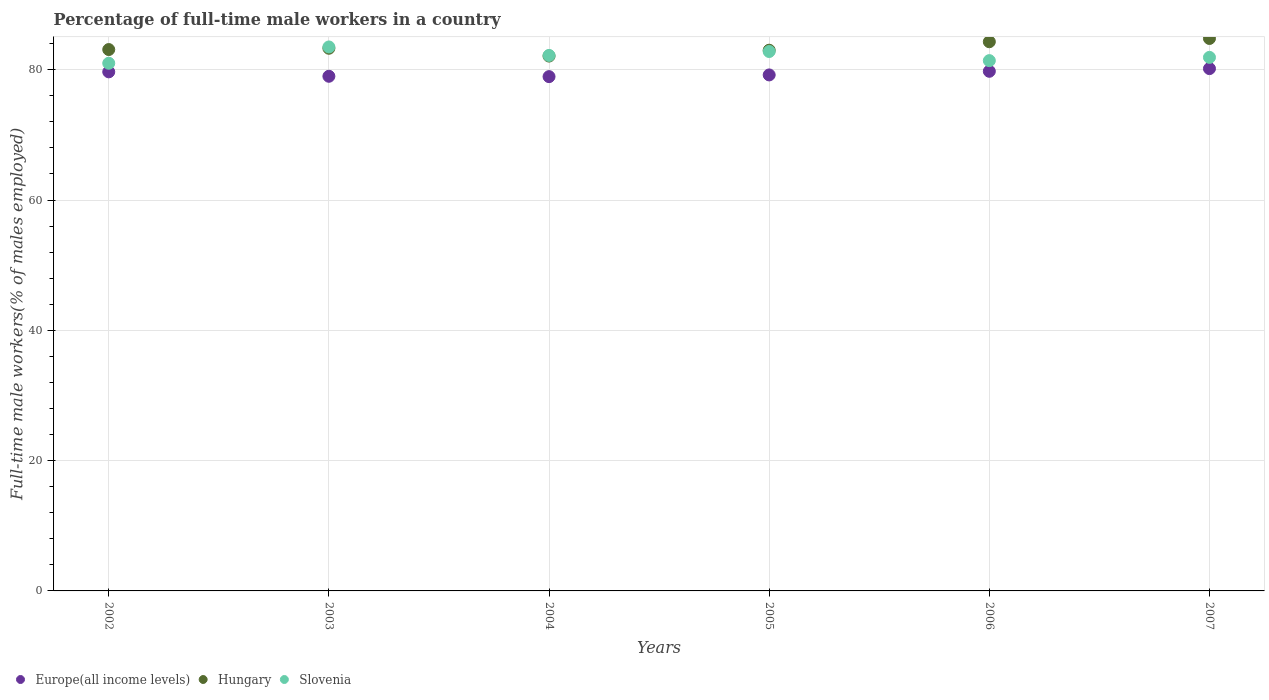Is the number of dotlines equal to the number of legend labels?
Offer a very short reply. Yes. What is the percentage of full-time male workers in Slovenia in 2006?
Offer a terse response. 81.4. Across all years, what is the maximum percentage of full-time male workers in Hungary?
Your answer should be very brief. 84.8. Across all years, what is the minimum percentage of full-time male workers in Europe(all income levels)?
Provide a short and direct response. 78.94. What is the total percentage of full-time male workers in Slovenia in the graph?
Provide a succinct answer. 492.8. What is the difference between the percentage of full-time male workers in Hungary in 2004 and that in 2005?
Ensure brevity in your answer.  -0.9. What is the difference between the percentage of full-time male workers in Europe(all income levels) in 2006 and the percentage of full-time male workers in Slovenia in 2004?
Provide a short and direct response. -2.44. What is the average percentage of full-time male workers in Europe(all income levels) per year?
Keep it short and to the point. 79.46. In the year 2007, what is the difference between the percentage of full-time male workers in Hungary and percentage of full-time male workers in Europe(all income levels)?
Provide a short and direct response. 4.63. What is the ratio of the percentage of full-time male workers in Slovenia in 2002 to that in 2006?
Your response must be concise. 1. Is the percentage of full-time male workers in Slovenia in 2004 less than that in 2007?
Ensure brevity in your answer.  No. Is the difference between the percentage of full-time male workers in Hungary in 2003 and 2006 greater than the difference between the percentage of full-time male workers in Europe(all income levels) in 2003 and 2006?
Provide a short and direct response. No. What is the difference between the highest and the second highest percentage of full-time male workers in Slovenia?
Ensure brevity in your answer.  0.7. What is the difference between the highest and the lowest percentage of full-time male workers in Europe(all income levels)?
Give a very brief answer. 1.23. Does the percentage of full-time male workers in Europe(all income levels) monotonically increase over the years?
Ensure brevity in your answer.  No. Is the percentage of full-time male workers in Hungary strictly less than the percentage of full-time male workers in Europe(all income levels) over the years?
Provide a short and direct response. No. How many years are there in the graph?
Your answer should be very brief. 6. What is the difference between two consecutive major ticks on the Y-axis?
Give a very brief answer. 20. Are the values on the major ticks of Y-axis written in scientific E-notation?
Offer a terse response. No. Does the graph contain any zero values?
Provide a short and direct response. No. Does the graph contain grids?
Provide a short and direct response. Yes. What is the title of the graph?
Keep it short and to the point. Percentage of full-time male workers in a country. What is the label or title of the X-axis?
Keep it short and to the point. Years. What is the label or title of the Y-axis?
Your response must be concise. Full-time male workers(% of males employed). What is the Full-time male workers(% of males employed) of Europe(all income levels) in 2002?
Offer a terse response. 79.68. What is the Full-time male workers(% of males employed) in Hungary in 2002?
Provide a succinct answer. 83.1. What is the Full-time male workers(% of males employed) of Europe(all income levels) in 2003?
Your answer should be very brief. 79. What is the Full-time male workers(% of males employed) of Hungary in 2003?
Ensure brevity in your answer.  83.3. What is the Full-time male workers(% of males employed) of Slovenia in 2003?
Offer a very short reply. 83.5. What is the Full-time male workers(% of males employed) in Europe(all income levels) in 2004?
Offer a terse response. 78.94. What is the Full-time male workers(% of males employed) of Hungary in 2004?
Your response must be concise. 82.1. What is the Full-time male workers(% of males employed) in Slovenia in 2004?
Make the answer very short. 82.2. What is the Full-time male workers(% of males employed) of Europe(all income levels) in 2005?
Offer a terse response. 79.21. What is the Full-time male workers(% of males employed) in Hungary in 2005?
Your answer should be very brief. 83. What is the Full-time male workers(% of males employed) of Slovenia in 2005?
Offer a terse response. 82.8. What is the Full-time male workers(% of males employed) in Europe(all income levels) in 2006?
Your answer should be compact. 79.76. What is the Full-time male workers(% of males employed) in Hungary in 2006?
Make the answer very short. 84.3. What is the Full-time male workers(% of males employed) in Slovenia in 2006?
Offer a very short reply. 81.4. What is the Full-time male workers(% of males employed) in Europe(all income levels) in 2007?
Offer a very short reply. 80.17. What is the Full-time male workers(% of males employed) in Hungary in 2007?
Ensure brevity in your answer.  84.8. What is the Full-time male workers(% of males employed) of Slovenia in 2007?
Give a very brief answer. 81.9. Across all years, what is the maximum Full-time male workers(% of males employed) of Europe(all income levels)?
Your answer should be compact. 80.17. Across all years, what is the maximum Full-time male workers(% of males employed) in Hungary?
Make the answer very short. 84.8. Across all years, what is the maximum Full-time male workers(% of males employed) of Slovenia?
Offer a terse response. 83.5. Across all years, what is the minimum Full-time male workers(% of males employed) in Europe(all income levels)?
Offer a terse response. 78.94. Across all years, what is the minimum Full-time male workers(% of males employed) in Hungary?
Provide a short and direct response. 82.1. Across all years, what is the minimum Full-time male workers(% of males employed) in Slovenia?
Your answer should be very brief. 81. What is the total Full-time male workers(% of males employed) of Europe(all income levels) in the graph?
Your answer should be compact. 476.77. What is the total Full-time male workers(% of males employed) of Hungary in the graph?
Offer a very short reply. 500.6. What is the total Full-time male workers(% of males employed) in Slovenia in the graph?
Give a very brief answer. 492.8. What is the difference between the Full-time male workers(% of males employed) of Europe(all income levels) in 2002 and that in 2003?
Your answer should be very brief. 0.68. What is the difference between the Full-time male workers(% of males employed) in Europe(all income levels) in 2002 and that in 2004?
Ensure brevity in your answer.  0.73. What is the difference between the Full-time male workers(% of males employed) of Slovenia in 2002 and that in 2004?
Give a very brief answer. -1.2. What is the difference between the Full-time male workers(% of males employed) of Europe(all income levels) in 2002 and that in 2005?
Keep it short and to the point. 0.47. What is the difference between the Full-time male workers(% of males employed) of Europe(all income levels) in 2002 and that in 2006?
Offer a very short reply. -0.09. What is the difference between the Full-time male workers(% of males employed) of Hungary in 2002 and that in 2006?
Offer a very short reply. -1.2. What is the difference between the Full-time male workers(% of males employed) of Europe(all income levels) in 2002 and that in 2007?
Provide a succinct answer. -0.5. What is the difference between the Full-time male workers(% of males employed) of Slovenia in 2002 and that in 2007?
Your answer should be compact. -0.9. What is the difference between the Full-time male workers(% of males employed) of Europe(all income levels) in 2003 and that in 2004?
Your answer should be compact. 0.05. What is the difference between the Full-time male workers(% of males employed) in Slovenia in 2003 and that in 2004?
Give a very brief answer. 1.3. What is the difference between the Full-time male workers(% of males employed) in Europe(all income levels) in 2003 and that in 2005?
Your answer should be very brief. -0.21. What is the difference between the Full-time male workers(% of males employed) of Europe(all income levels) in 2003 and that in 2006?
Your answer should be compact. -0.77. What is the difference between the Full-time male workers(% of males employed) in Slovenia in 2003 and that in 2006?
Make the answer very short. 2.1. What is the difference between the Full-time male workers(% of males employed) of Europe(all income levels) in 2003 and that in 2007?
Offer a terse response. -1.18. What is the difference between the Full-time male workers(% of males employed) of Hungary in 2003 and that in 2007?
Ensure brevity in your answer.  -1.5. What is the difference between the Full-time male workers(% of males employed) in Slovenia in 2003 and that in 2007?
Ensure brevity in your answer.  1.6. What is the difference between the Full-time male workers(% of males employed) in Europe(all income levels) in 2004 and that in 2005?
Offer a very short reply. -0.26. What is the difference between the Full-time male workers(% of males employed) in Hungary in 2004 and that in 2005?
Provide a short and direct response. -0.9. What is the difference between the Full-time male workers(% of males employed) in Slovenia in 2004 and that in 2005?
Your answer should be compact. -0.6. What is the difference between the Full-time male workers(% of males employed) of Europe(all income levels) in 2004 and that in 2006?
Provide a succinct answer. -0.82. What is the difference between the Full-time male workers(% of males employed) of Slovenia in 2004 and that in 2006?
Provide a short and direct response. 0.8. What is the difference between the Full-time male workers(% of males employed) in Europe(all income levels) in 2004 and that in 2007?
Your answer should be compact. -1.23. What is the difference between the Full-time male workers(% of males employed) of Hungary in 2004 and that in 2007?
Your answer should be very brief. -2.7. What is the difference between the Full-time male workers(% of males employed) of Europe(all income levels) in 2005 and that in 2006?
Your answer should be very brief. -0.56. What is the difference between the Full-time male workers(% of males employed) in Europe(all income levels) in 2005 and that in 2007?
Your answer should be very brief. -0.97. What is the difference between the Full-time male workers(% of males employed) in Hungary in 2005 and that in 2007?
Your answer should be very brief. -1.8. What is the difference between the Full-time male workers(% of males employed) of Slovenia in 2005 and that in 2007?
Give a very brief answer. 0.9. What is the difference between the Full-time male workers(% of males employed) in Europe(all income levels) in 2006 and that in 2007?
Give a very brief answer. -0.41. What is the difference between the Full-time male workers(% of males employed) of Hungary in 2006 and that in 2007?
Offer a terse response. -0.5. What is the difference between the Full-time male workers(% of males employed) of Slovenia in 2006 and that in 2007?
Ensure brevity in your answer.  -0.5. What is the difference between the Full-time male workers(% of males employed) in Europe(all income levels) in 2002 and the Full-time male workers(% of males employed) in Hungary in 2003?
Offer a very short reply. -3.62. What is the difference between the Full-time male workers(% of males employed) in Europe(all income levels) in 2002 and the Full-time male workers(% of males employed) in Slovenia in 2003?
Keep it short and to the point. -3.82. What is the difference between the Full-time male workers(% of males employed) in Hungary in 2002 and the Full-time male workers(% of males employed) in Slovenia in 2003?
Your response must be concise. -0.4. What is the difference between the Full-time male workers(% of males employed) in Europe(all income levels) in 2002 and the Full-time male workers(% of males employed) in Hungary in 2004?
Your answer should be very brief. -2.42. What is the difference between the Full-time male workers(% of males employed) of Europe(all income levels) in 2002 and the Full-time male workers(% of males employed) of Slovenia in 2004?
Give a very brief answer. -2.52. What is the difference between the Full-time male workers(% of males employed) of Hungary in 2002 and the Full-time male workers(% of males employed) of Slovenia in 2004?
Keep it short and to the point. 0.9. What is the difference between the Full-time male workers(% of males employed) in Europe(all income levels) in 2002 and the Full-time male workers(% of males employed) in Hungary in 2005?
Your response must be concise. -3.32. What is the difference between the Full-time male workers(% of males employed) in Europe(all income levels) in 2002 and the Full-time male workers(% of males employed) in Slovenia in 2005?
Your answer should be compact. -3.12. What is the difference between the Full-time male workers(% of males employed) in Europe(all income levels) in 2002 and the Full-time male workers(% of males employed) in Hungary in 2006?
Ensure brevity in your answer.  -4.62. What is the difference between the Full-time male workers(% of males employed) in Europe(all income levels) in 2002 and the Full-time male workers(% of males employed) in Slovenia in 2006?
Your answer should be compact. -1.72. What is the difference between the Full-time male workers(% of males employed) in Europe(all income levels) in 2002 and the Full-time male workers(% of males employed) in Hungary in 2007?
Your answer should be compact. -5.12. What is the difference between the Full-time male workers(% of males employed) in Europe(all income levels) in 2002 and the Full-time male workers(% of males employed) in Slovenia in 2007?
Make the answer very short. -2.22. What is the difference between the Full-time male workers(% of males employed) of Europe(all income levels) in 2003 and the Full-time male workers(% of males employed) of Hungary in 2004?
Your response must be concise. -3.1. What is the difference between the Full-time male workers(% of males employed) in Europe(all income levels) in 2003 and the Full-time male workers(% of males employed) in Slovenia in 2004?
Keep it short and to the point. -3.2. What is the difference between the Full-time male workers(% of males employed) of Hungary in 2003 and the Full-time male workers(% of males employed) of Slovenia in 2004?
Your answer should be compact. 1.1. What is the difference between the Full-time male workers(% of males employed) in Europe(all income levels) in 2003 and the Full-time male workers(% of males employed) in Hungary in 2005?
Offer a terse response. -4. What is the difference between the Full-time male workers(% of males employed) of Europe(all income levels) in 2003 and the Full-time male workers(% of males employed) of Slovenia in 2005?
Offer a very short reply. -3.8. What is the difference between the Full-time male workers(% of males employed) of Hungary in 2003 and the Full-time male workers(% of males employed) of Slovenia in 2005?
Make the answer very short. 0.5. What is the difference between the Full-time male workers(% of males employed) in Europe(all income levels) in 2003 and the Full-time male workers(% of males employed) in Hungary in 2006?
Provide a short and direct response. -5.3. What is the difference between the Full-time male workers(% of males employed) of Europe(all income levels) in 2003 and the Full-time male workers(% of males employed) of Slovenia in 2006?
Your answer should be very brief. -2.4. What is the difference between the Full-time male workers(% of males employed) in Hungary in 2003 and the Full-time male workers(% of males employed) in Slovenia in 2006?
Your answer should be compact. 1.9. What is the difference between the Full-time male workers(% of males employed) in Europe(all income levels) in 2003 and the Full-time male workers(% of males employed) in Hungary in 2007?
Your answer should be very brief. -5.8. What is the difference between the Full-time male workers(% of males employed) of Europe(all income levels) in 2003 and the Full-time male workers(% of males employed) of Slovenia in 2007?
Keep it short and to the point. -2.9. What is the difference between the Full-time male workers(% of males employed) of Hungary in 2003 and the Full-time male workers(% of males employed) of Slovenia in 2007?
Give a very brief answer. 1.4. What is the difference between the Full-time male workers(% of males employed) in Europe(all income levels) in 2004 and the Full-time male workers(% of males employed) in Hungary in 2005?
Your answer should be very brief. -4.06. What is the difference between the Full-time male workers(% of males employed) of Europe(all income levels) in 2004 and the Full-time male workers(% of males employed) of Slovenia in 2005?
Offer a very short reply. -3.86. What is the difference between the Full-time male workers(% of males employed) of Europe(all income levels) in 2004 and the Full-time male workers(% of males employed) of Hungary in 2006?
Give a very brief answer. -5.36. What is the difference between the Full-time male workers(% of males employed) in Europe(all income levels) in 2004 and the Full-time male workers(% of males employed) in Slovenia in 2006?
Ensure brevity in your answer.  -2.46. What is the difference between the Full-time male workers(% of males employed) of Hungary in 2004 and the Full-time male workers(% of males employed) of Slovenia in 2006?
Provide a short and direct response. 0.7. What is the difference between the Full-time male workers(% of males employed) of Europe(all income levels) in 2004 and the Full-time male workers(% of males employed) of Hungary in 2007?
Give a very brief answer. -5.86. What is the difference between the Full-time male workers(% of males employed) of Europe(all income levels) in 2004 and the Full-time male workers(% of males employed) of Slovenia in 2007?
Your answer should be compact. -2.96. What is the difference between the Full-time male workers(% of males employed) in Europe(all income levels) in 2005 and the Full-time male workers(% of males employed) in Hungary in 2006?
Give a very brief answer. -5.09. What is the difference between the Full-time male workers(% of males employed) in Europe(all income levels) in 2005 and the Full-time male workers(% of males employed) in Slovenia in 2006?
Your answer should be compact. -2.19. What is the difference between the Full-time male workers(% of males employed) of Europe(all income levels) in 2005 and the Full-time male workers(% of males employed) of Hungary in 2007?
Give a very brief answer. -5.59. What is the difference between the Full-time male workers(% of males employed) in Europe(all income levels) in 2005 and the Full-time male workers(% of males employed) in Slovenia in 2007?
Provide a succinct answer. -2.69. What is the difference between the Full-time male workers(% of males employed) of Hungary in 2005 and the Full-time male workers(% of males employed) of Slovenia in 2007?
Your answer should be very brief. 1.1. What is the difference between the Full-time male workers(% of males employed) of Europe(all income levels) in 2006 and the Full-time male workers(% of males employed) of Hungary in 2007?
Offer a terse response. -5.04. What is the difference between the Full-time male workers(% of males employed) in Europe(all income levels) in 2006 and the Full-time male workers(% of males employed) in Slovenia in 2007?
Keep it short and to the point. -2.14. What is the average Full-time male workers(% of males employed) of Europe(all income levels) per year?
Your answer should be very brief. 79.46. What is the average Full-time male workers(% of males employed) of Hungary per year?
Ensure brevity in your answer.  83.43. What is the average Full-time male workers(% of males employed) of Slovenia per year?
Give a very brief answer. 82.13. In the year 2002, what is the difference between the Full-time male workers(% of males employed) in Europe(all income levels) and Full-time male workers(% of males employed) in Hungary?
Make the answer very short. -3.42. In the year 2002, what is the difference between the Full-time male workers(% of males employed) of Europe(all income levels) and Full-time male workers(% of males employed) of Slovenia?
Your answer should be very brief. -1.32. In the year 2003, what is the difference between the Full-time male workers(% of males employed) in Europe(all income levels) and Full-time male workers(% of males employed) in Hungary?
Offer a terse response. -4.3. In the year 2003, what is the difference between the Full-time male workers(% of males employed) in Europe(all income levels) and Full-time male workers(% of males employed) in Slovenia?
Keep it short and to the point. -4.5. In the year 2003, what is the difference between the Full-time male workers(% of males employed) of Hungary and Full-time male workers(% of males employed) of Slovenia?
Your response must be concise. -0.2. In the year 2004, what is the difference between the Full-time male workers(% of males employed) of Europe(all income levels) and Full-time male workers(% of males employed) of Hungary?
Offer a very short reply. -3.16. In the year 2004, what is the difference between the Full-time male workers(% of males employed) of Europe(all income levels) and Full-time male workers(% of males employed) of Slovenia?
Provide a succinct answer. -3.26. In the year 2005, what is the difference between the Full-time male workers(% of males employed) in Europe(all income levels) and Full-time male workers(% of males employed) in Hungary?
Offer a terse response. -3.79. In the year 2005, what is the difference between the Full-time male workers(% of males employed) in Europe(all income levels) and Full-time male workers(% of males employed) in Slovenia?
Provide a succinct answer. -3.59. In the year 2005, what is the difference between the Full-time male workers(% of males employed) in Hungary and Full-time male workers(% of males employed) in Slovenia?
Give a very brief answer. 0.2. In the year 2006, what is the difference between the Full-time male workers(% of males employed) of Europe(all income levels) and Full-time male workers(% of males employed) of Hungary?
Offer a very short reply. -4.54. In the year 2006, what is the difference between the Full-time male workers(% of males employed) in Europe(all income levels) and Full-time male workers(% of males employed) in Slovenia?
Provide a short and direct response. -1.64. In the year 2006, what is the difference between the Full-time male workers(% of males employed) of Hungary and Full-time male workers(% of males employed) of Slovenia?
Make the answer very short. 2.9. In the year 2007, what is the difference between the Full-time male workers(% of males employed) in Europe(all income levels) and Full-time male workers(% of males employed) in Hungary?
Ensure brevity in your answer.  -4.63. In the year 2007, what is the difference between the Full-time male workers(% of males employed) of Europe(all income levels) and Full-time male workers(% of males employed) of Slovenia?
Keep it short and to the point. -1.73. What is the ratio of the Full-time male workers(% of males employed) in Europe(all income levels) in 2002 to that in 2003?
Your answer should be compact. 1.01. What is the ratio of the Full-time male workers(% of males employed) of Hungary in 2002 to that in 2003?
Make the answer very short. 1. What is the ratio of the Full-time male workers(% of males employed) in Slovenia in 2002 to that in 2003?
Give a very brief answer. 0.97. What is the ratio of the Full-time male workers(% of males employed) in Europe(all income levels) in 2002 to that in 2004?
Offer a very short reply. 1.01. What is the ratio of the Full-time male workers(% of males employed) in Hungary in 2002 to that in 2004?
Provide a succinct answer. 1.01. What is the ratio of the Full-time male workers(% of males employed) in Slovenia in 2002 to that in 2004?
Your answer should be very brief. 0.99. What is the ratio of the Full-time male workers(% of males employed) in Hungary in 2002 to that in 2005?
Give a very brief answer. 1. What is the ratio of the Full-time male workers(% of males employed) in Slovenia in 2002 to that in 2005?
Your response must be concise. 0.98. What is the ratio of the Full-time male workers(% of males employed) of Hungary in 2002 to that in 2006?
Offer a terse response. 0.99. What is the ratio of the Full-time male workers(% of males employed) in Hungary in 2002 to that in 2007?
Make the answer very short. 0.98. What is the ratio of the Full-time male workers(% of males employed) of Europe(all income levels) in 2003 to that in 2004?
Provide a succinct answer. 1. What is the ratio of the Full-time male workers(% of males employed) of Hungary in 2003 to that in 2004?
Your answer should be very brief. 1.01. What is the ratio of the Full-time male workers(% of males employed) in Slovenia in 2003 to that in 2004?
Ensure brevity in your answer.  1.02. What is the ratio of the Full-time male workers(% of males employed) of Europe(all income levels) in 2003 to that in 2005?
Ensure brevity in your answer.  1. What is the ratio of the Full-time male workers(% of males employed) of Hungary in 2003 to that in 2005?
Make the answer very short. 1. What is the ratio of the Full-time male workers(% of males employed) in Slovenia in 2003 to that in 2005?
Provide a short and direct response. 1.01. What is the ratio of the Full-time male workers(% of males employed) of Slovenia in 2003 to that in 2006?
Offer a terse response. 1.03. What is the ratio of the Full-time male workers(% of males employed) of Hungary in 2003 to that in 2007?
Your response must be concise. 0.98. What is the ratio of the Full-time male workers(% of males employed) in Slovenia in 2003 to that in 2007?
Make the answer very short. 1.02. What is the ratio of the Full-time male workers(% of males employed) of Europe(all income levels) in 2004 to that in 2005?
Offer a terse response. 1. What is the ratio of the Full-time male workers(% of males employed) in Hungary in 2004 to that in 2005?
Keep it short and to the point. 0.99. What is the ratio of the Full-time male workers(% of males employed) in Hungary in 2004 to that in 2006?
Give a very brief answer. 0.97. What is the ratio of the Full-time male workers(% of males employed) of Slovenia in 2004 to that in 2006?
Your answer should be very brief. 1.01. What is the ratio of the Full-time male workers(% of males employed) in Europe(all income levels) in 2004 to that in 2007?
Keep it short and to the point. 0.98. What is the ratio of the Full-time male workers(% of males employed) of Hungary in 2004 to that in 2007?
Offer a terse response. 0.97. What is the ratio of the Full-time male workers(% of males employed) in Europe(all income levels) in 2005 to that in 2006?
Your answer should be compact. 0.99. What is the ratio of the Full-time male workers(% of males employed) in Hungary in 2005 to that in 2006?
Provide a succinct answer. 0.98. What is the ratio of the Full-time male workers(% of males employed) in Slovenia in 2005 to that in 2006?
Your answer should be very brief. 1.02. What is the ratio of the Full-time male workers(% of males employed) of Europe(all income levels) in 2005 to that in 2007?
Ensure brevity in your answer.  0.99. What is the ratio of the Full-time male workers(% of males employed) of Hungary in 2005 to that in 2007?
Offer a terse response. 0.98. What is the ratio of the Full-time male workers(% of males employed) in Europe(all income levels) in 2006 to that in 2007?
Ensure brevity in your answer.  0.99. What is the ratio of the Full-time male workers(% of males employed) of Slovenia in 2006 to that in 2007?
Give a very brief answer. 0.99. What is the difference between the highest and the second highest Full-time male workers(% of males employed) of Europe(all income levels)?
Give a very brief answer. 0.41. What is the difference between the highest and the second highest Full-time male workers(% of males employed) of Hungary?
Offer a terse response. 0.5. What is the difference between the highest and the second highest Full-time male workers(% of males employed) in Slovenia?
Your answer should be very brief. 0.7. What is the difference between the highest and the lowest Full-time male workers(% of males employed) of Europe(all income levels)?
Your answer should be compact. 1.23. What is the difference between the highest and the lowest Full-time male workers(% of males employed) in Hungary?
Your answer should be compact. 2.7. 